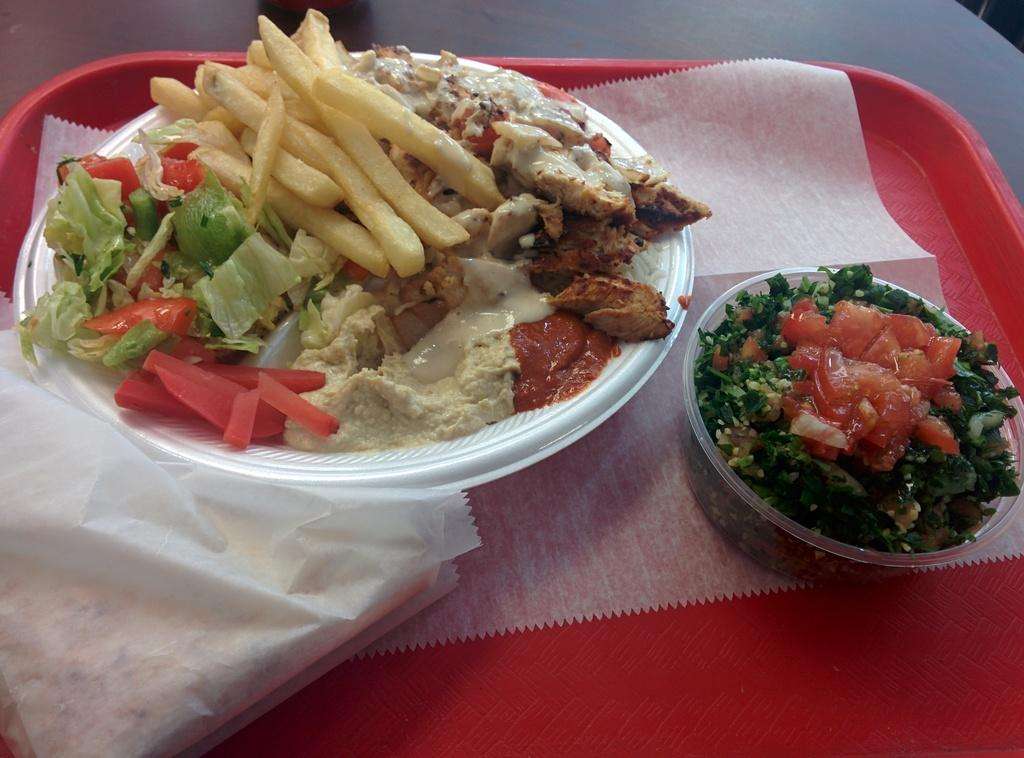What color is the plate in the image? The plate in the image is red. What type of food is on the plate? French fries, tomato slices, and chopped coriander are on the plate. Can you describe the arrangement of the food on the plate? The French fries, tomato slices, and chopped coriander are all placed on the red plate. What type of game is being played on the plate in the image? There is no game being played on the plate in the image; it contains food items. Can you see a wren perched on the plate in the image? There is no wren present in the image; it features a red plate with food items. 